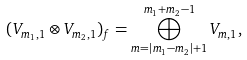Convert formula to latex. <formula><loc_0><loc_0><loc_500><loc_500>( V _ { m _ { 1 } , 1 } \otimes V _ { m _ { 2 } , 1 } ) _ { f } = \bigoplus _ { m = | m _ { 1 } - m _ { 2 } | + 1 } ^ { m _ { 1 } + m _ { 2 } - 1 } V _ { m , 1 } ,</formula> 